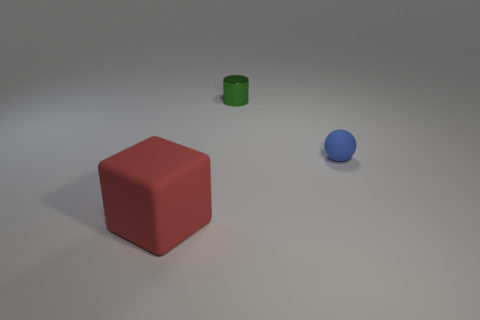Are there any other things that have the same shape as the tiny blue object?
Keep it short and to the point. No. Is there anything else that is the same size as the red rubber object?
Give a very brief answer. No. There is a small object in front of the tiny metal object; are there any matte objects in front of it?
Provide a succinct answer. Yes. There is a thing on the left side of the tiny green cylinder that is to the left of the matte thing to the right of the tiny green shiny object; what is its size?
Give a very brief answer. Large. What material is the thing in front of the tiny object in front of the small green cylinder made of?
Ensure brevity in your answer.  Rubber. The small rubber object is what shape?
Your response must be concise. Sphere. What is the material of the green cylinder behind the matte thing that is behind the thing on the left side of the small green metal thing?
Offer a terse response. Metal. Is the number of large red cubes that are in front of the blue matte sphere greater than the number of tiny red shiny things?
Make the answer very short. Yes. What material is the green object that is the same size as the blue matte object?
Your answer should be compact. Metal. Is there a thing of the same size as the matte ball?
Provide a succinct answer. Yes. 